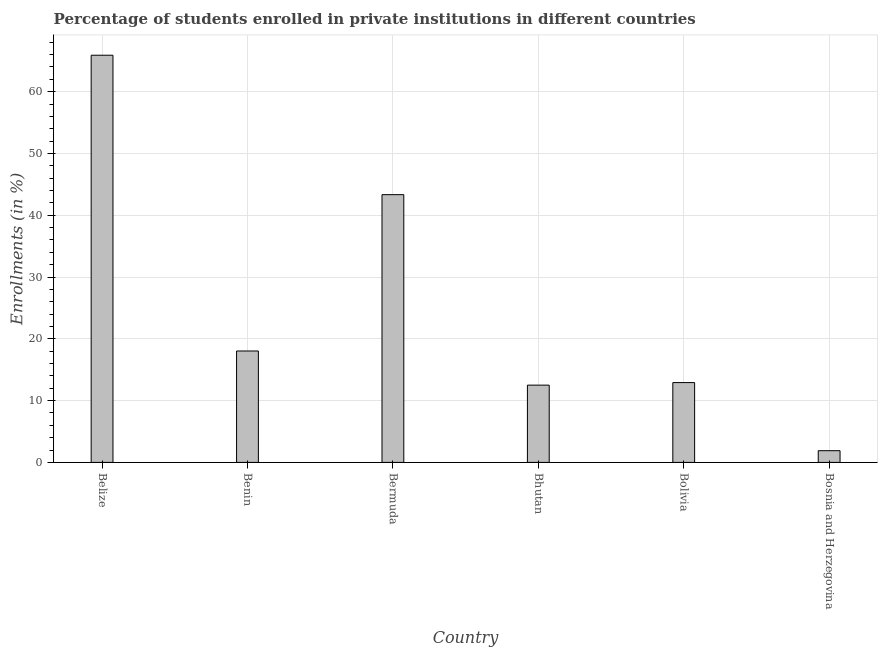Does the graph contain any zero values?
Offer a very short reply. No. Does the graph contain grids?
Provide a succinct answer. Yes. What is the title of the graph?
Keep it short and to the point. Percentage of students enrolled in private institutions in different countries. What is the label or title of the X-axis?
Offer a terse response. Country. What is the label or title of the Y-axis?
Make the answer very short. Enrollments (in %). What is the enrollments in private institutions in Bolivia?
Provide a succinct answer. 12.92. Across all countries, what is the maximum enrollments in private institutions?
Your answer should be very brief. 65.9. Across all countries, what is the minimum enrollments in private institutions?
Provide a succinct answer. 1.89. In which country was the enrollments in private institutions maximum?
Offer a terse response. Belize. In which country was the enrollments in private institutions minimum?
Keep it short and to the point. Bosnia and Herzegovina. What is the sum of the enrollments in private institutions?
Provide a short and direct response. 154.57. What is the difference between the enrollments in private institutions in Belize and Bhutan?
Offer a terse response. 53.39. What is the average enrollments in private institutions per country?
Offer a very short reply. 25.76. What is the median enrollments in private institutions?
Your answer should be very brief. 15.47. In how many countries, is the enrollments in private institutions greater than 52 %?
Provide a succinct answer. 1. Is the enrollments in private institutions in Benin less than that in Bhutan?
Your response must be concise. No. Is the difference between the enrollments in private institutions in Bhutan and Bolivia greater than the difference between any two countries?
Keep it short and to the point. No. What is the difference between the highest and the second highest enrollments in private institutions?
Your answer should be compact. 22.57. Is the sum of the enrollments in private institutions in Belize and Bermuda greater than the maximum enrollments in private institutions across all countries?
Offer a terse response. Yes. What is the difference between the highest and the lowest enrollments in private institutions?
Ensure brevity in your answer.  64. In how many countries, is the enrollments in private institutions greater than the average enrollments in private institutions taken over all countries?
Provide a short and direct response. 2. How many bars are there?
Keep it short and to the point. 6. What is the Enrollments (in %) in Belize?
Provide a short and direct response. 65.9. What is the Enrollments (in %) of Benin?
Provide a short and direct response. 18.03. What is the Enrollments (in %) of Bermuda?
Offer a very short reply. 43.33. What is the Enrollments (in %) in Bhutan?
Make the answer very short. 12.5. What is the Enrollments (in %) of Bolivia?
Provide a succinct answer. 12.92. What is the Enrollments (in %) of Bosnia and Herzegovina?
Provide a short and direct response. 1.89. What is the difference between the Enrollments (in %) in Belize and Benin?
Offer a terse response. 47.87. What is the difference between the Enrollments (in %) in Belize and Bermuda?
Offer a very short reply. 22.57. What is the difference between the Enrollments (in %) in Belize and Bhutan?
Keep it short and to the point. 53.39. What is the difference between the Enrollments (in %) in Belize and Bolivia?
Keep it short and to the point. 52.98. What is the difference between the Enrollments (in %) in Belize and Bosnia and Herzegovina?
Your response must be concise. 64. What is the difference between the Enrollments (in %) in Benin and Bermuda?
Provide a succinct answer. -25.3. What is the difference between the Enrollments (in %) in Benin and Bhutan?
Your response must be concise. 5.53. What is the difference between the Enrollments (in %) in Benin and Bolivia?
Keep it short and to the point. 5.11. What is the difference between the Enrollments (in %) in Benin and Bosnia and Herzegovina?
Keep it short and to the point. 16.14. What is the difference between the Enrollments (in %) in Bermuda and Bhutan?
Offer a terse response. 30.83. What is the difference between the Enrollments (in %) in Bermuda and Bolivia?
Your answer should be very brief. 30.41. What is the difference between the Enrollments (in %) in Bermuda and Bosnia and Herzegovina?
Keep it short and to the point. 41.44. What is the difference between the Enrollments (in %) in Bhutan and Bolivia?
Your response must be concise. -0.41. What is the difference between the Enrollments (in %) in Bhutan and Bosnia and Herzegovina?
Give a very brief answer. 10.61. What is the difference between the Enrollments (in %) in Bolivia and Bosnia and Herzegovina?
Offer a terse response. 11.02. What is the ratio of the Enrollments (in %) in Belize to that in Benin?
Offer a terse response. 3.65. What is the ratio of the Enrollments (in %) in Belize to that in Bermuda?
Offer a terse response. 1.52. What is the ratio of the Enrollments (in %) in Belize to that in Bhutan?
Ensure brevity in your answer.  5.27. What is the ratio of the Enrollments (in %) in Belize to that in Bolivia?
Your answer should be compact. 5.1. What is the ratio of the Enrollments (in %) in Belize to that in Bosnia and Herzegovina?
Give a very brief answer. 34.8. What is the ratio of the Enrollments (in %) in Benin to that in Bermuda?
Your answer should be very brief. 0.42. What is the ratio of the Enrollments (in %) in Benin to that in Bhutan?
Give a very brief answer. 1.44. What is the ratio of the Enrollments (in %) in Benin to that in Bolivia?
Make the answer very short. 1.4. What is the ratio of the Enrollments (in %) in Benin to that in Bosnia and Herzegovina?
Keep it short and to the point. 9.52. What is the ratio of the Enrollments (in %) in Bermuda to that in Bhutan?
Your answer should be very brief. 3.46. What is the ratio of the Enrollments (in %) in Bermuda to that in Bolivia?
Your answer should be very brief. 3.35. What is the ratio of the Enrollments (in %) in Bermuda to that in Bosnia and Herzegovina?
Your answer should be very brief. 22.88. What is the ratio of the Enrollments (in %) in Bhutan to that in Bolivia?
Your answer should be very brief. 0.97. What is the ratio of the Enrollments (in %) in Bhutan to that in Bosnia and Herzegovina?
Your response must be concise. 6.6. What is the ratio of the Enrollments (in %) in Bolivia to that in Bosnia and Herzegovina?
Provide a succinct answer. 6.82. 